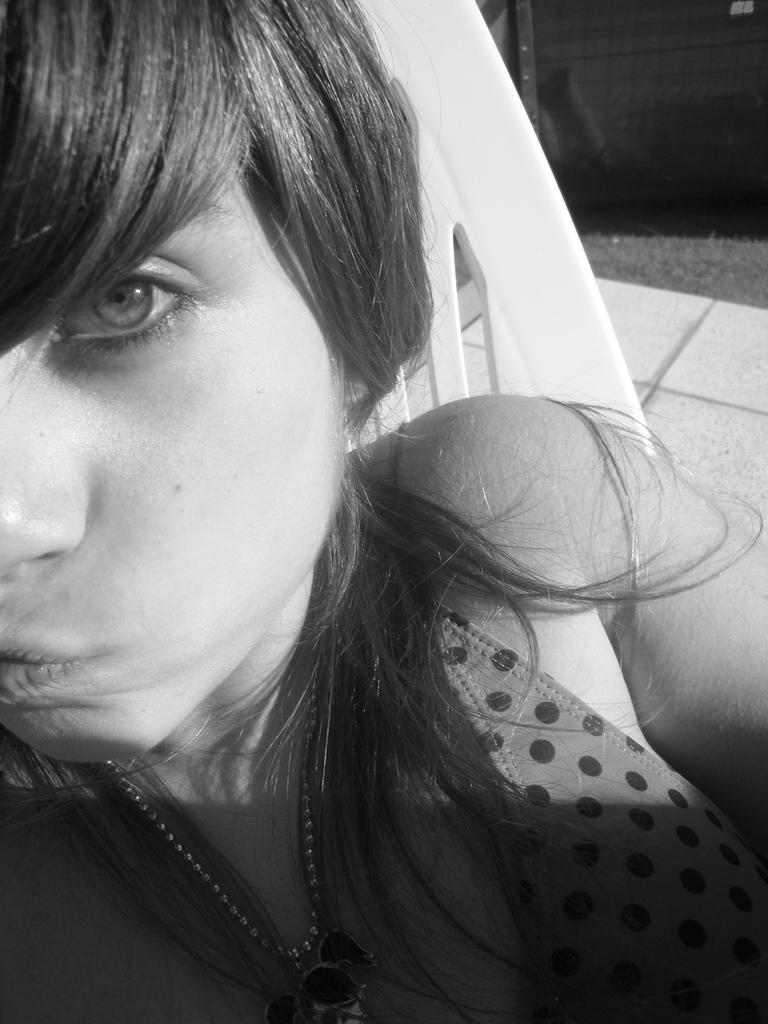Who is present in the image? There is a woman in the image. What is the woman doing in the image? The woman is sitting on a chair. What can be seen behind the woman in the image? There is a wall in the background of the image. What is the surface beneath the woman's feet in the image? There is a floor visible in the image. What type of list can be seen hanging from the icicle in the image? There is no list or icicle present in the image. 